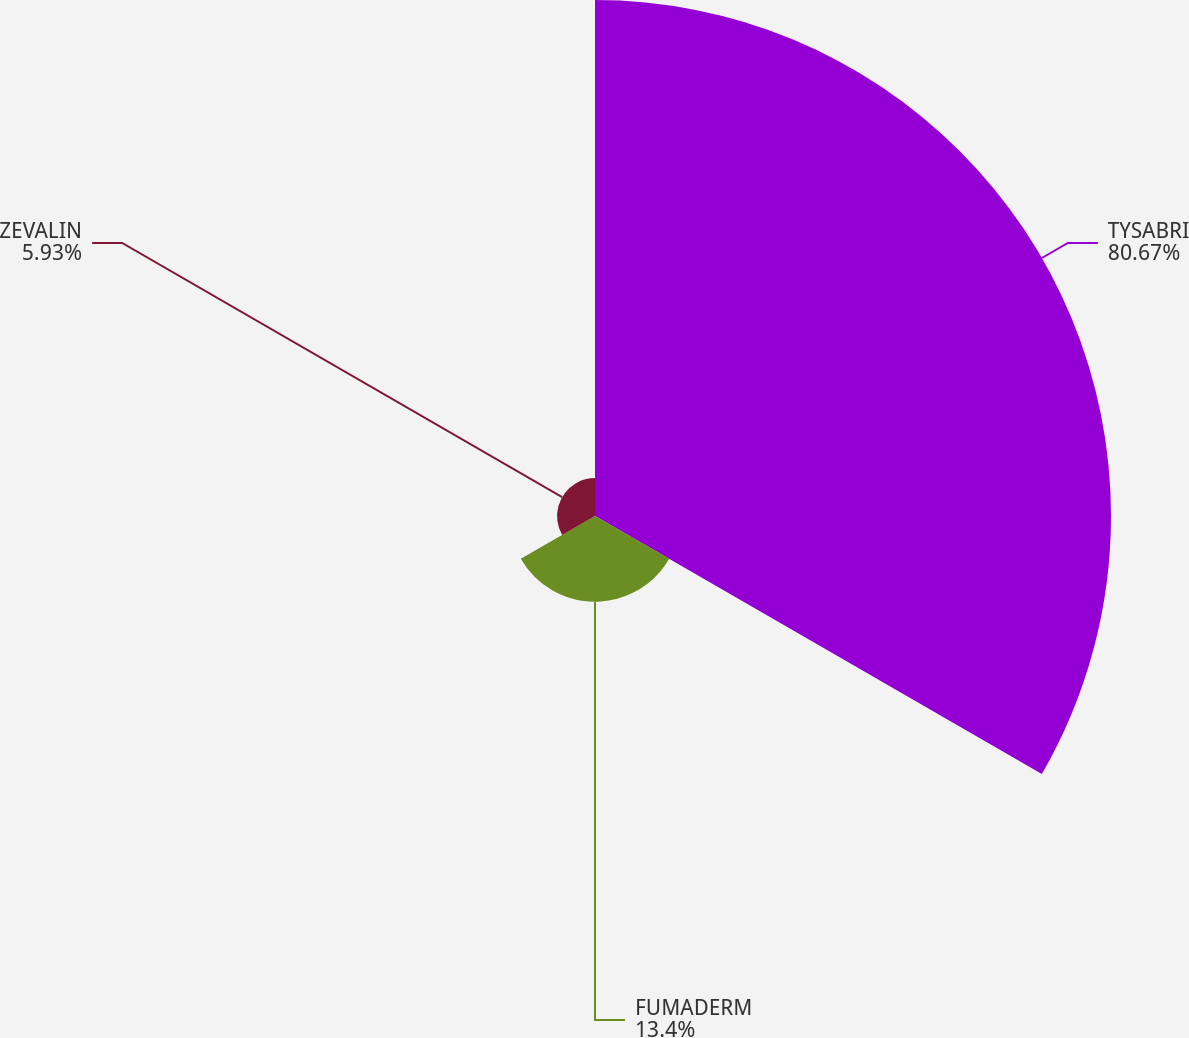Convert chart. <chart><loc_0><loc_0><loc_500><loc_500><pie_chart><fcel>TYSABRI<fcel>FUMADERM<fcel>ZEVALIN<nl><fcel>80.67%<fcel>13.4%<fcel>5.93%<nl></chart> 